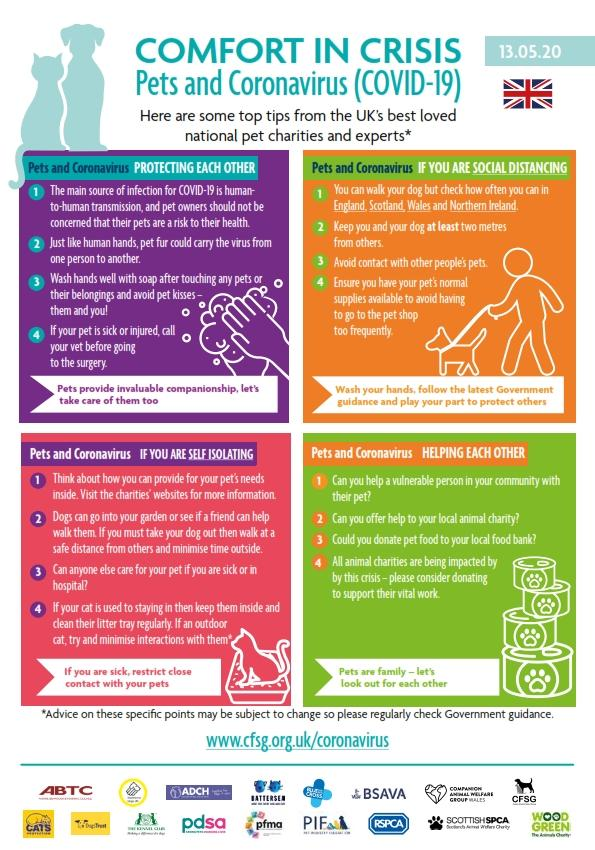Point out several critical features in this image. There are four points under the heading "Pets and Coronavirus helping each other. There are four points under the heading "Pets and Coronavirus Protecting Each Other. 